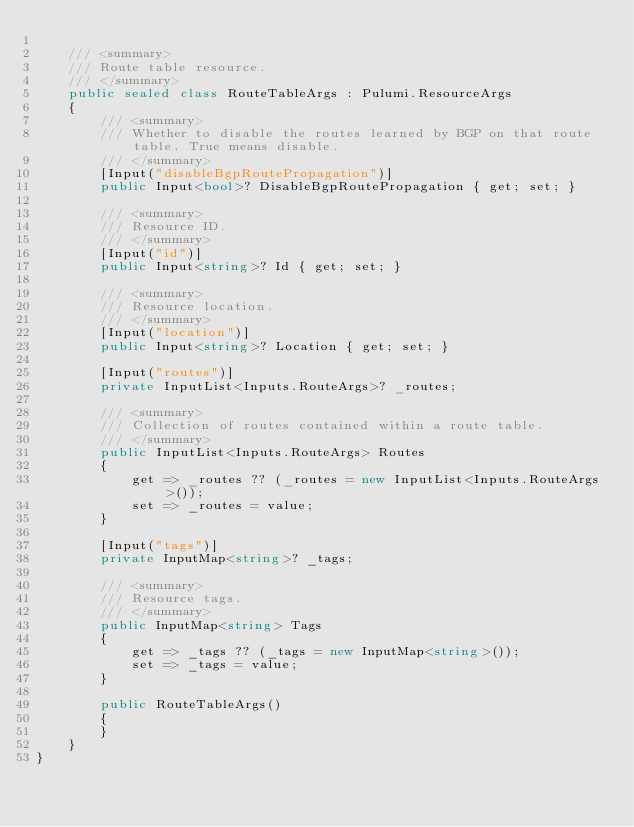Convert code to text. <code><loc_0><loc_0><loc_500><loc_500><_C#_>
    /// <summary>
    /// Route table resource.
    /// </summary>
    public sealed class RouteTableArgs : Pulumi.ResourceArgs
    {
        /// <summary>
        /// Whether to disable the routes learned by BGP on that route table. True means disable.
        /// </summary>
        [Input("disableBgpRoutePropagation")]
        public Input<bool>? DisableBgpRoutePropagation { get; set; }

        /// <summary>
        /// Resource ID.
        /// </summary>
        [Input("id")]
        public Input<string>? Id { get; set; }

        /// <summary>
        /// Resource location.
        /// </summary>
        [Input("location")]
        public Input<string>? Location { get; set; }

        [Input("routes")]
        private InputList<Inputs.RouteArgs>? _routes;

        /// <summary>
        /// Collection of routes contained within a route table.
        /// </summary>
        public InputList<Inputs.RouteArgs> Routes
        {
            get => _routes ?? (_routes = new InputList<Inputs.RouteArgs>());
            set => _routes = value;
        }

        [Input("tags")]
        private InputMap<string>? _tags;

        /// <summary>
        /// Resource tags.
        /// </summary>
        public InputMap<string> Tags
        {
            get => _tags ?? (_tags = new InputMap<string>());
            set => _tags = value;
        }

        public RouteTableArgs()
        {
        }
    }
}
</code> 